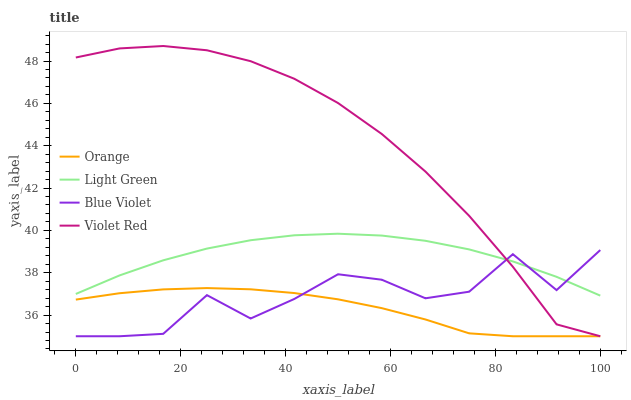Does Orange have the minimum area under the curve?
Answer yes or no. Yes. Does Violet Red have the maximum area under the curve?
Answer yes or no. Yes. Does Blue Violet have the minimum area under the curve?
Answer yes or no. No. Does Blue Violet have the maximum area under the curve?
Answer yes or no. No. Is Orange the smoothest?
Answer yes or no. Yes. Is Blue Violet the roughest?
Answer yes or no. Yes. Is Violet Red the smoothest?
Answer yes or no. No. Is Violet Red the roughest?
Answer yes or no. No. Does Light Green have the lowest value?
Answer yes or no. No. Does Blue Violet have the highest value?
Answer yes or no. No. Is Orange less than Light Green?
Answer yes or no. Yes. Is Light Green greater than Orange?
Answer yes or no. Yes. Does Orange intersect Light Green?
Answer yes or no. No. 